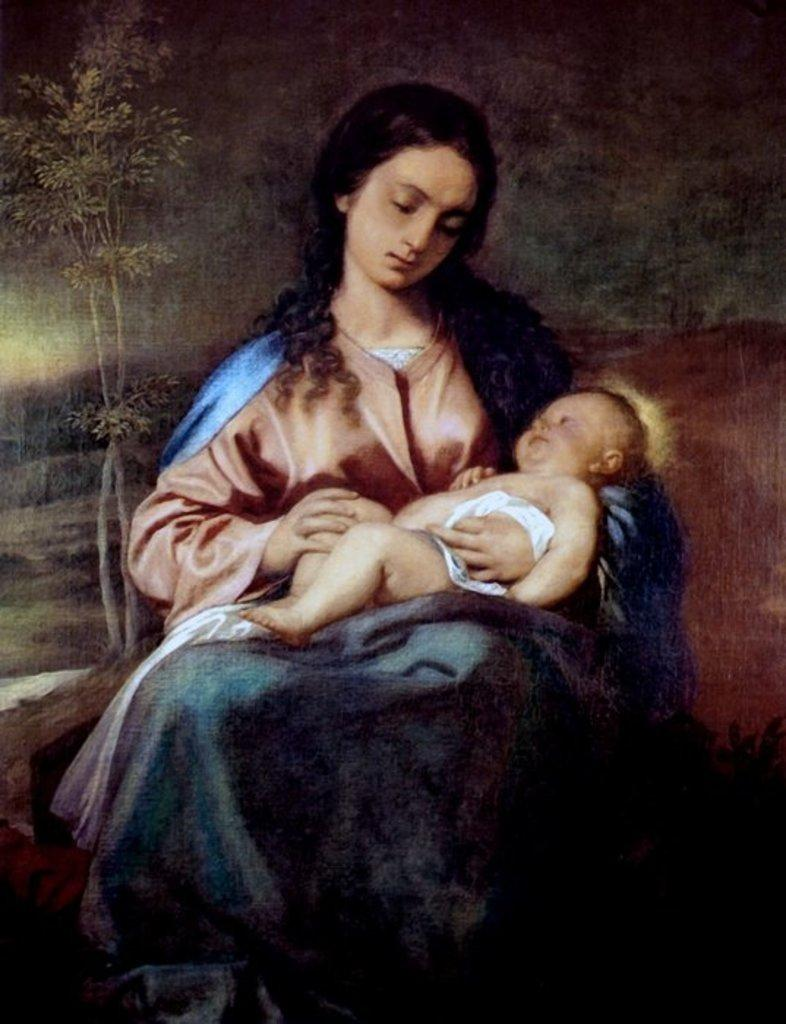What is depicted on the poster in the image? The poster contains a painting of a woman. What is the woman wearing in the painting? The woman is wearing a pink top in the painting. What is the woman holding in the painting? The woman is holding a small baby in her hand in the painting. What other object can be seen in the painting? There is a small plant visible in the painting. Can you see any clovers in the painting on the poster? There are no clovers visible in the painting on the poster. Is there a guitar featured in the painting on the poster? There is no guitar present in the painting on the poster. 